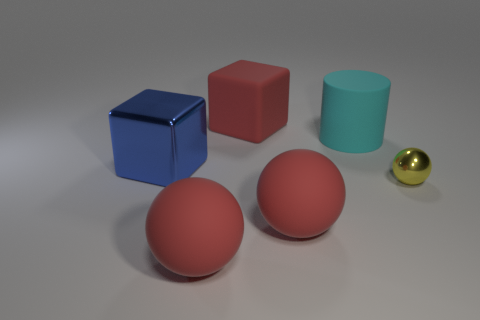Is there a big red object that is behind the blue metallic cube left of the large red rubber cube?
Provide a short and direct response. Yes. Are there any other things that have the same shape as the big cyan matte thing?
Offer a very short reply. No. Is the red cube the same size as the cyan cylinder?
Offer a terse response. Yes. There is a big ball that is in front of the big ball on the right side of the red rubber object that is behind the blue shiny object; what is it made of?
Offer a terse response. Rubber. Are there the same number of yellow things on the left side of the red matte block and gray objects?
Keep it short and to the point. Yes. Is there anything else that has the same size as the yellow shiny ball?
Provide a succinct answer. No. What number of things are either small yellow metallic spheres or blocks?
Make the answer very short. 3. There is a big blue thing that is the same material as the small yellow ball; what shape is it?
Offer a terse response. Cube. There is a red sphere that is to the left of the red ball that is on the right side of the red cube; how big is it?
Your response must be concise. Large. What number of big objects are purple shiny blocks or rubber things?
Provide a succinct answer. 4. 